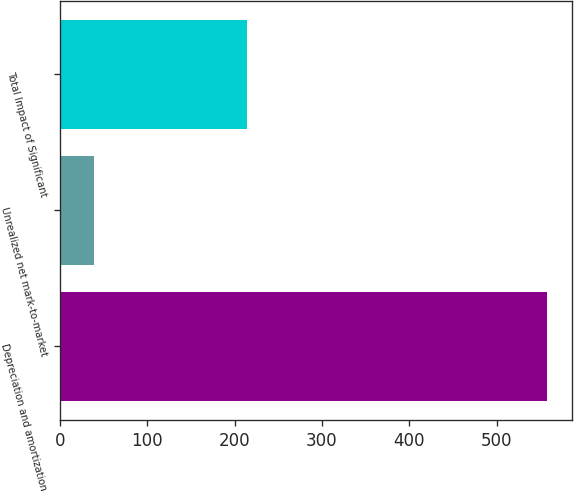Convert chart. <chart><loc_0><loc_0><loc_500><loc_500><bar_chart><fcel>Depreciation and amortization<fcel>Unrealized net mark-to-market<fcel>Total Impact of Significant<nl><fcel>558<fcel>39<fcel>214<nl></chart> 